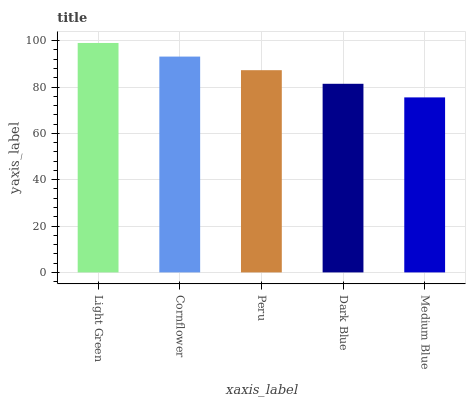Is Medium Blue the minimum?
Answer yes or no. Yes. Is Light Green the maximum?
Answer yes or no. Yes. Is Cornflower the minimum?
Answer yes or no. No. Is Cornflower the maximum?
Answer yes or no. No. Is Light Green greater than Cornflower?
Answer yes or no. Yes. Is Cornflower less than Light Green?
Answer yes or no. Yes. Is Cornflower greater than Light Green?
Answer yes or no. No. Is Light Green less than Cornflower?
Answer yes or no. No. Is Peru the high median?
Answer yes or no. Yes. Is Peru the low median?
Answer yes or no. Yes. Is Dark Blue the high median?
Answer yes or no. No. Is Medium Blue the low median?
Answer yes or no. No. 